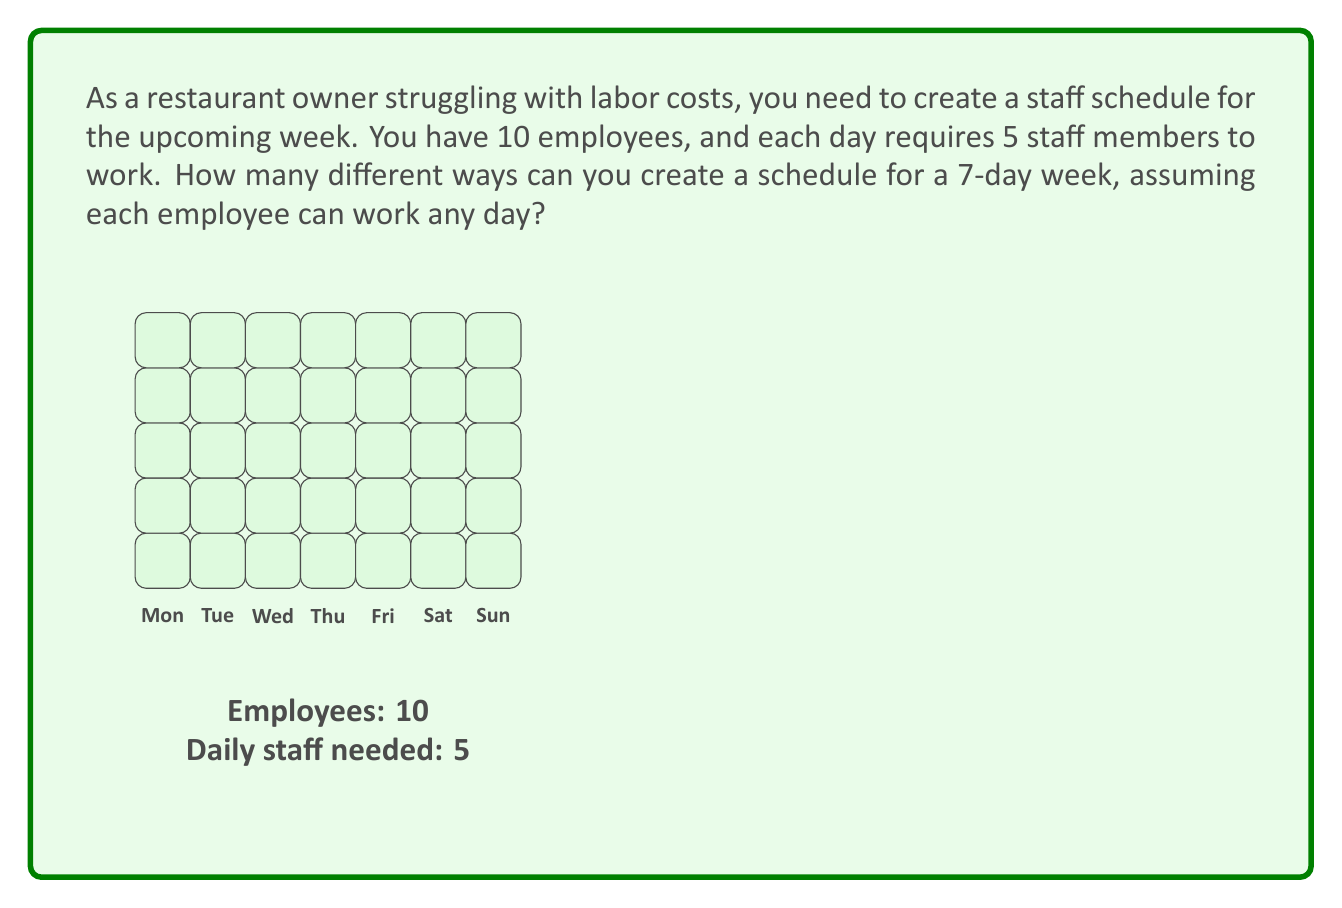Show me your answer to this math problem. Let's approach this step-by-step:

1) For each day, we need to choose 5 employees out of 10. This is a combination problem.

2) The number of ways to choose 5 employees out of 10 for a single day is:

   $$\binom{10}{5} = \frac{10!}{5!(10-5)!} = \frac{10!}{5!5!} = 252$$

3) We need to make this choice for each of the 7 days of the week.

4) Since the choices for each day are independent, we multiply the number of possibilities for each day.

5) Therefore, the total number of possible schedules is:

   $$252^7$$

6) Calculating this:
   
   $$252^7 = 3,221,225,472 \times 252 = 811,749,219,944$$

This large number demonstrates the complexity of scheduling even for a small restaurant, highlighting the potential benefit of optimization tools to manage labor costs effectively.
Answer: $252^7 = 811,749,219,944$ 